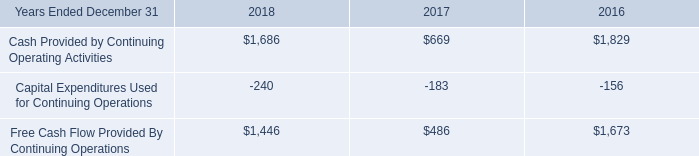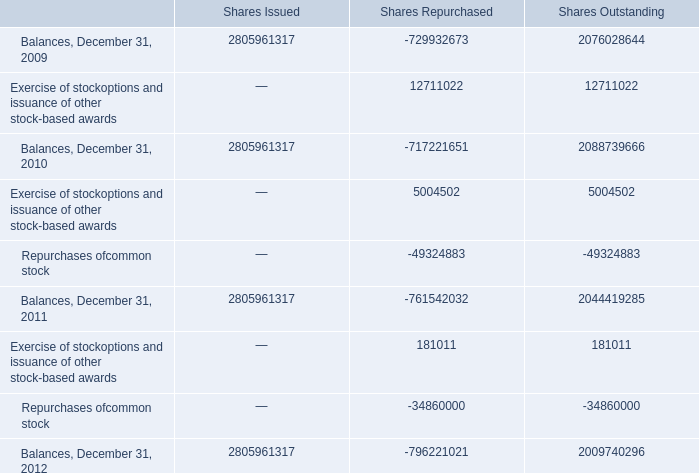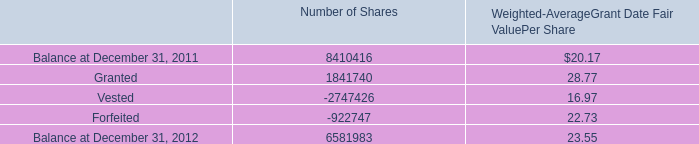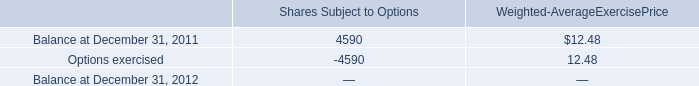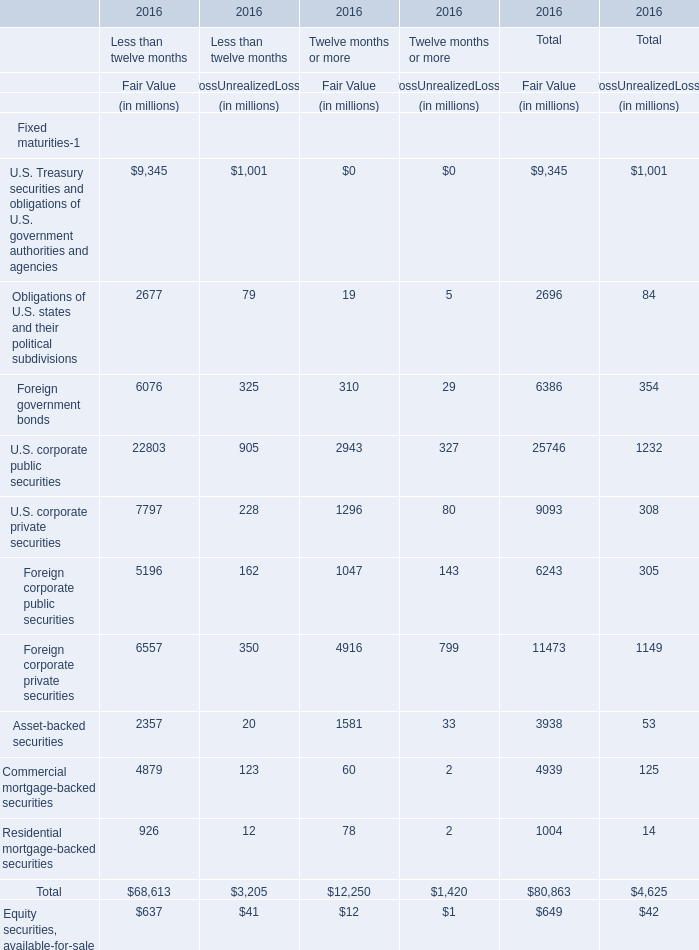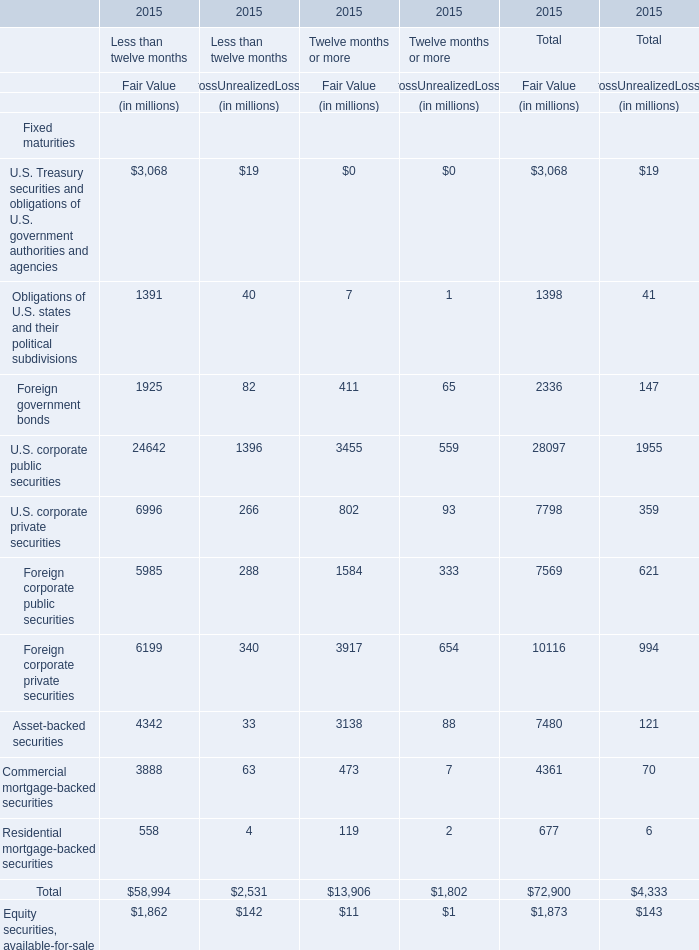What's the average of Repurchases ofcommon stock of Shares Outstanding, and Forfeited of Number of Shares ? 
Computations: ((49324883.0 + 922747.0) / 2)
Answer: 25123815.0. 